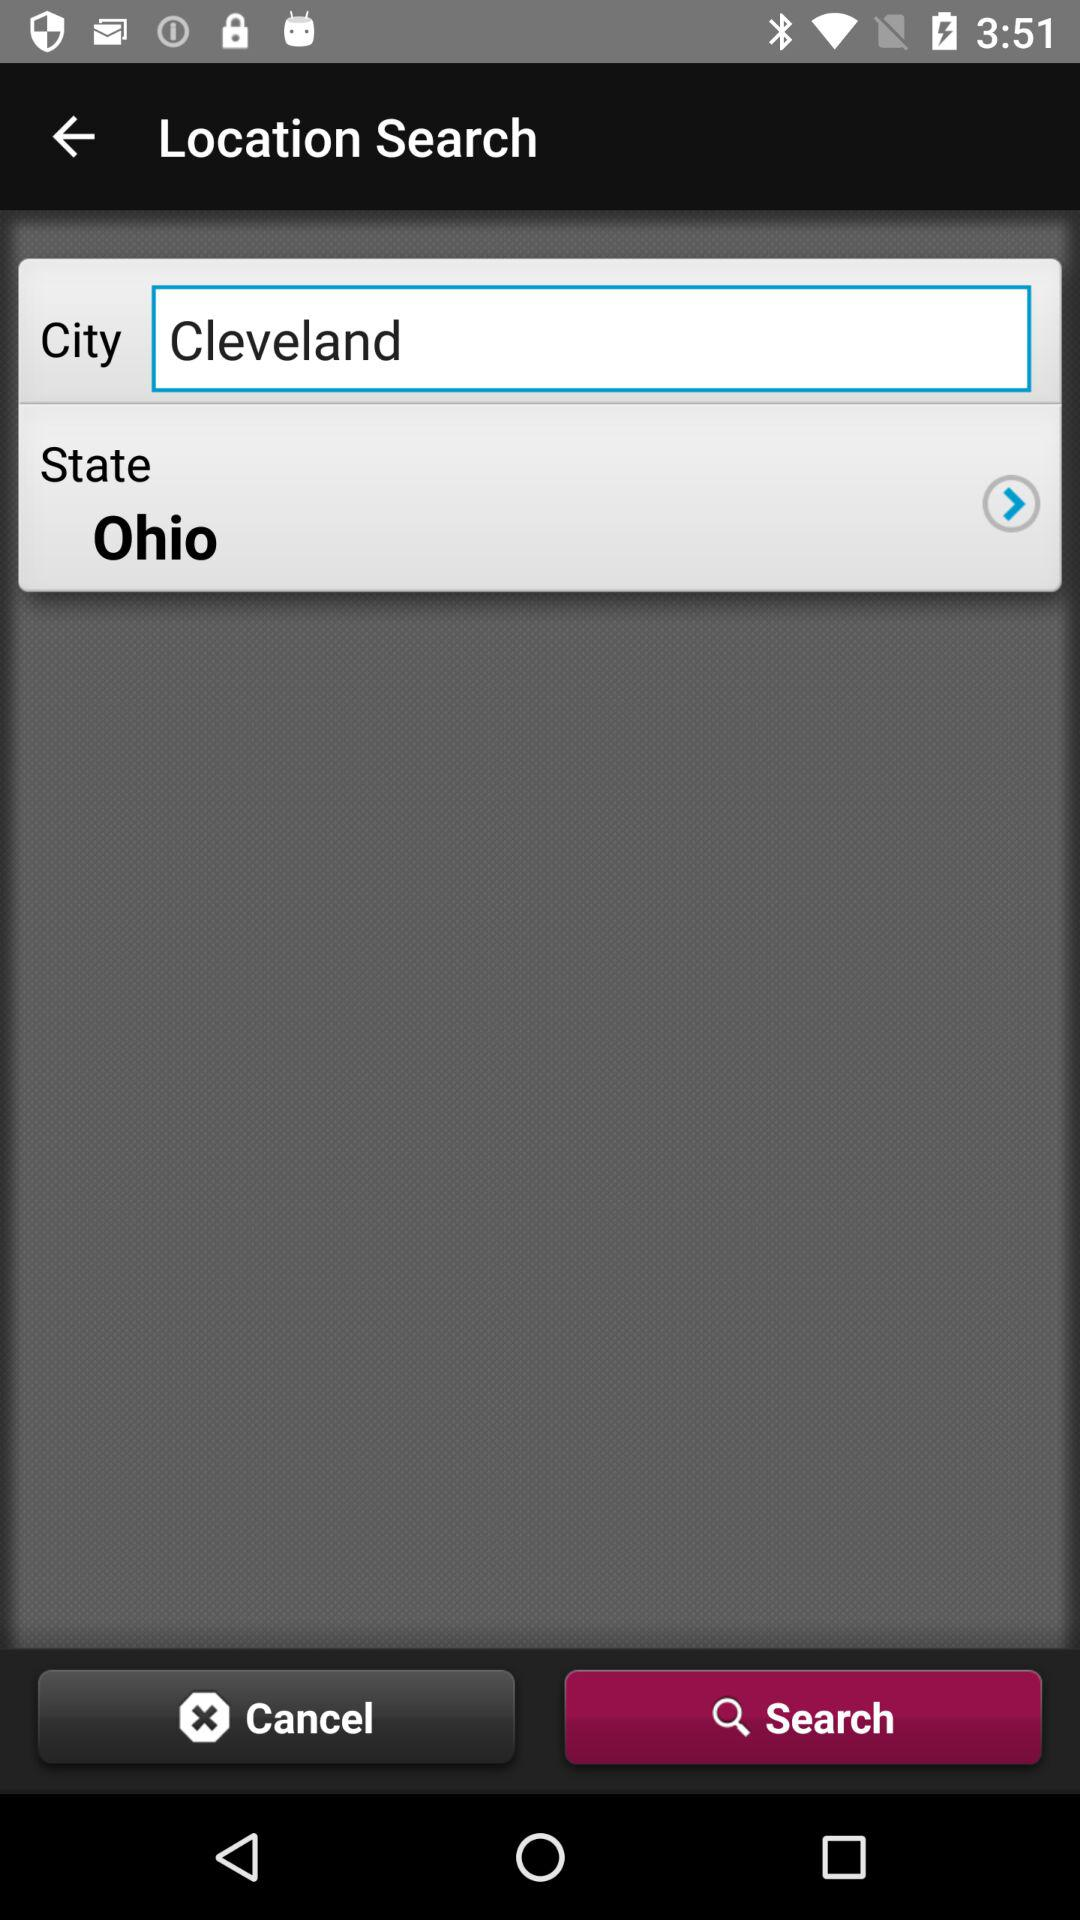What is the selected state? The selected state is Ohio. 